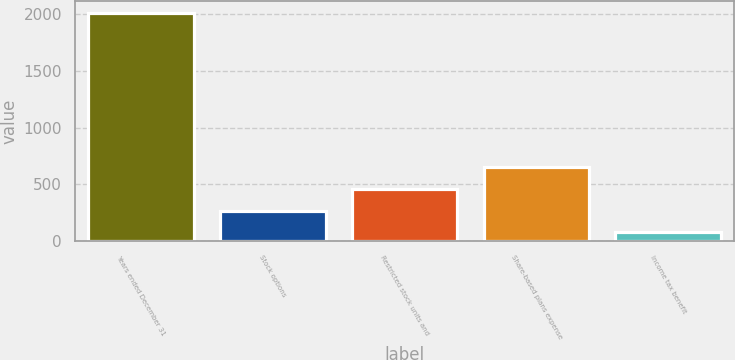Convert chart to OTSL. <chart><loc_0><loc_0><loc_500><loc_500><bar_chart><fcel>Years ended December 31<fcel>Stock options<fcel>Restricted stock units and<fcel>Share-based plans expense<fcel>Income tax benefit<nl><fcel>2012<fcel>268.7<fcel>462.4<fcel>656.1<fcel>75<nl></chart> 